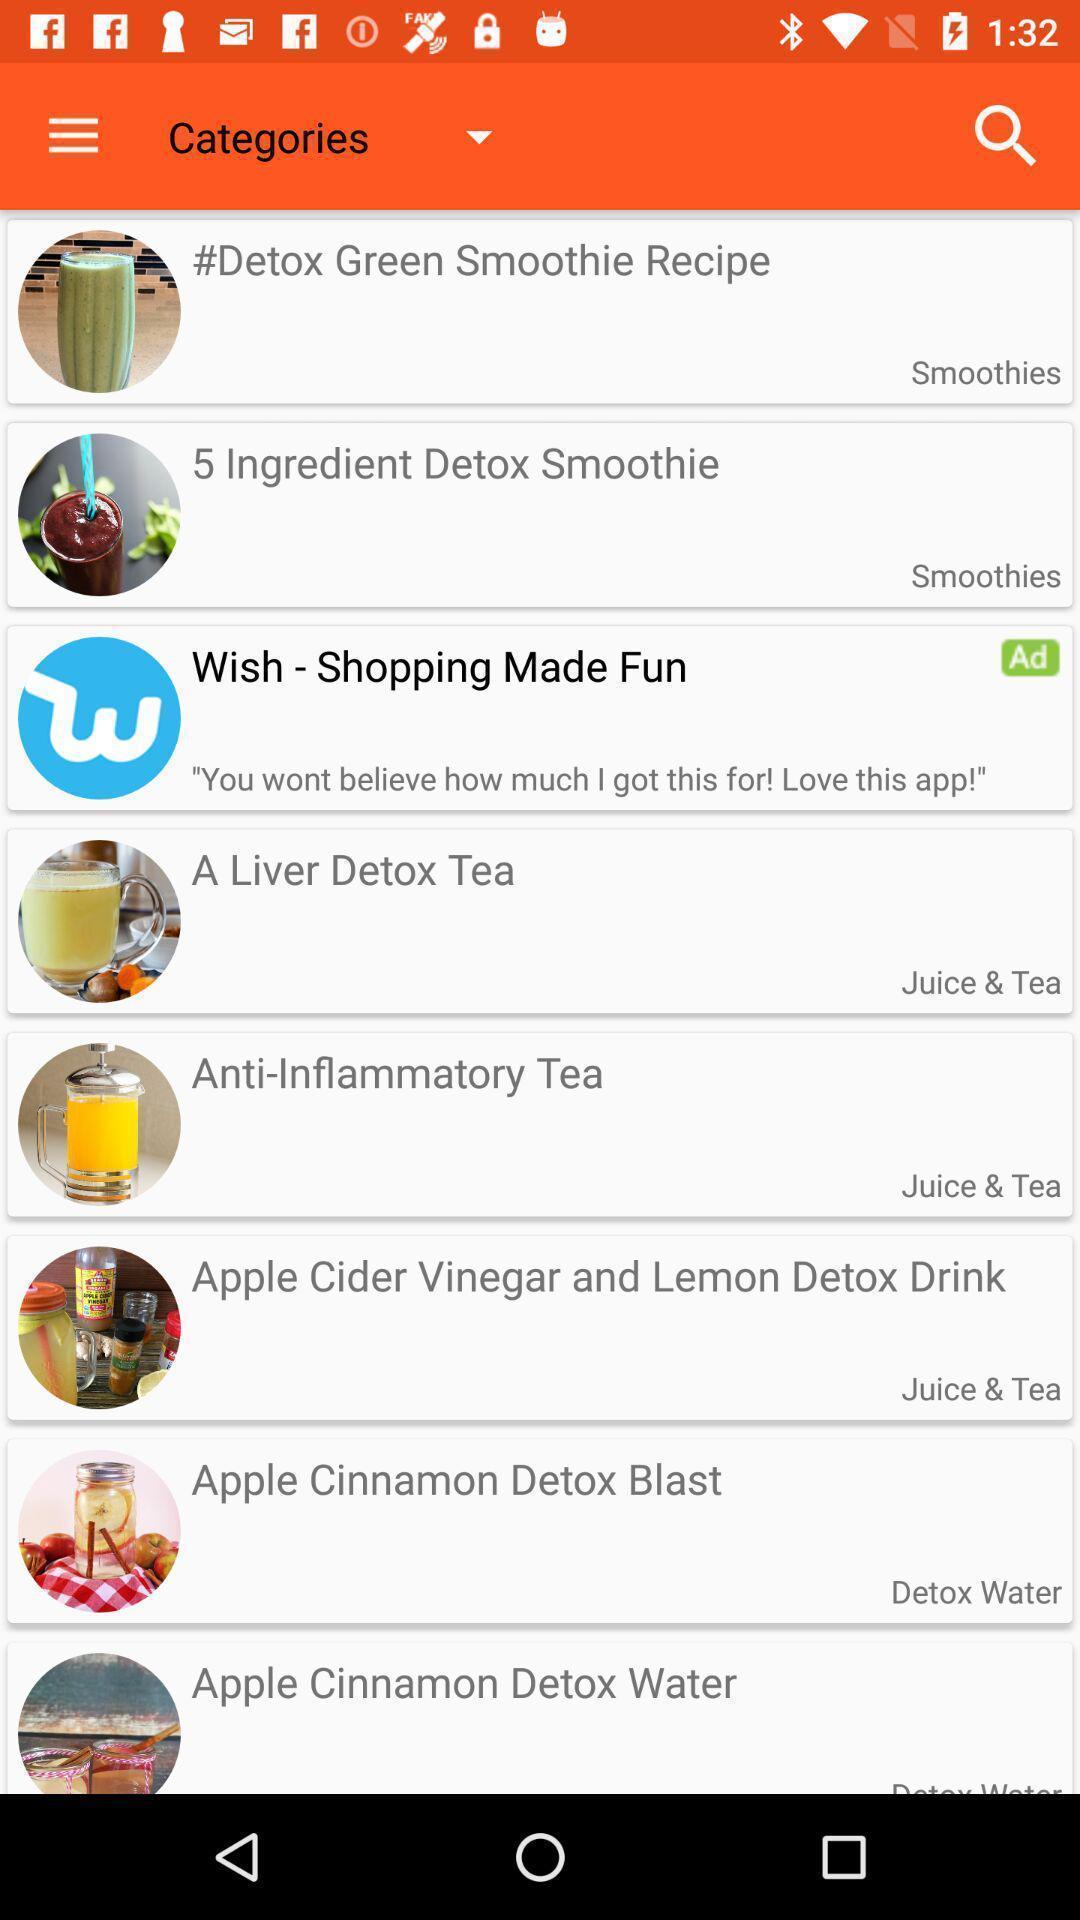Summarize the main components in this picture. Screen showing list of various categories of a food app. 